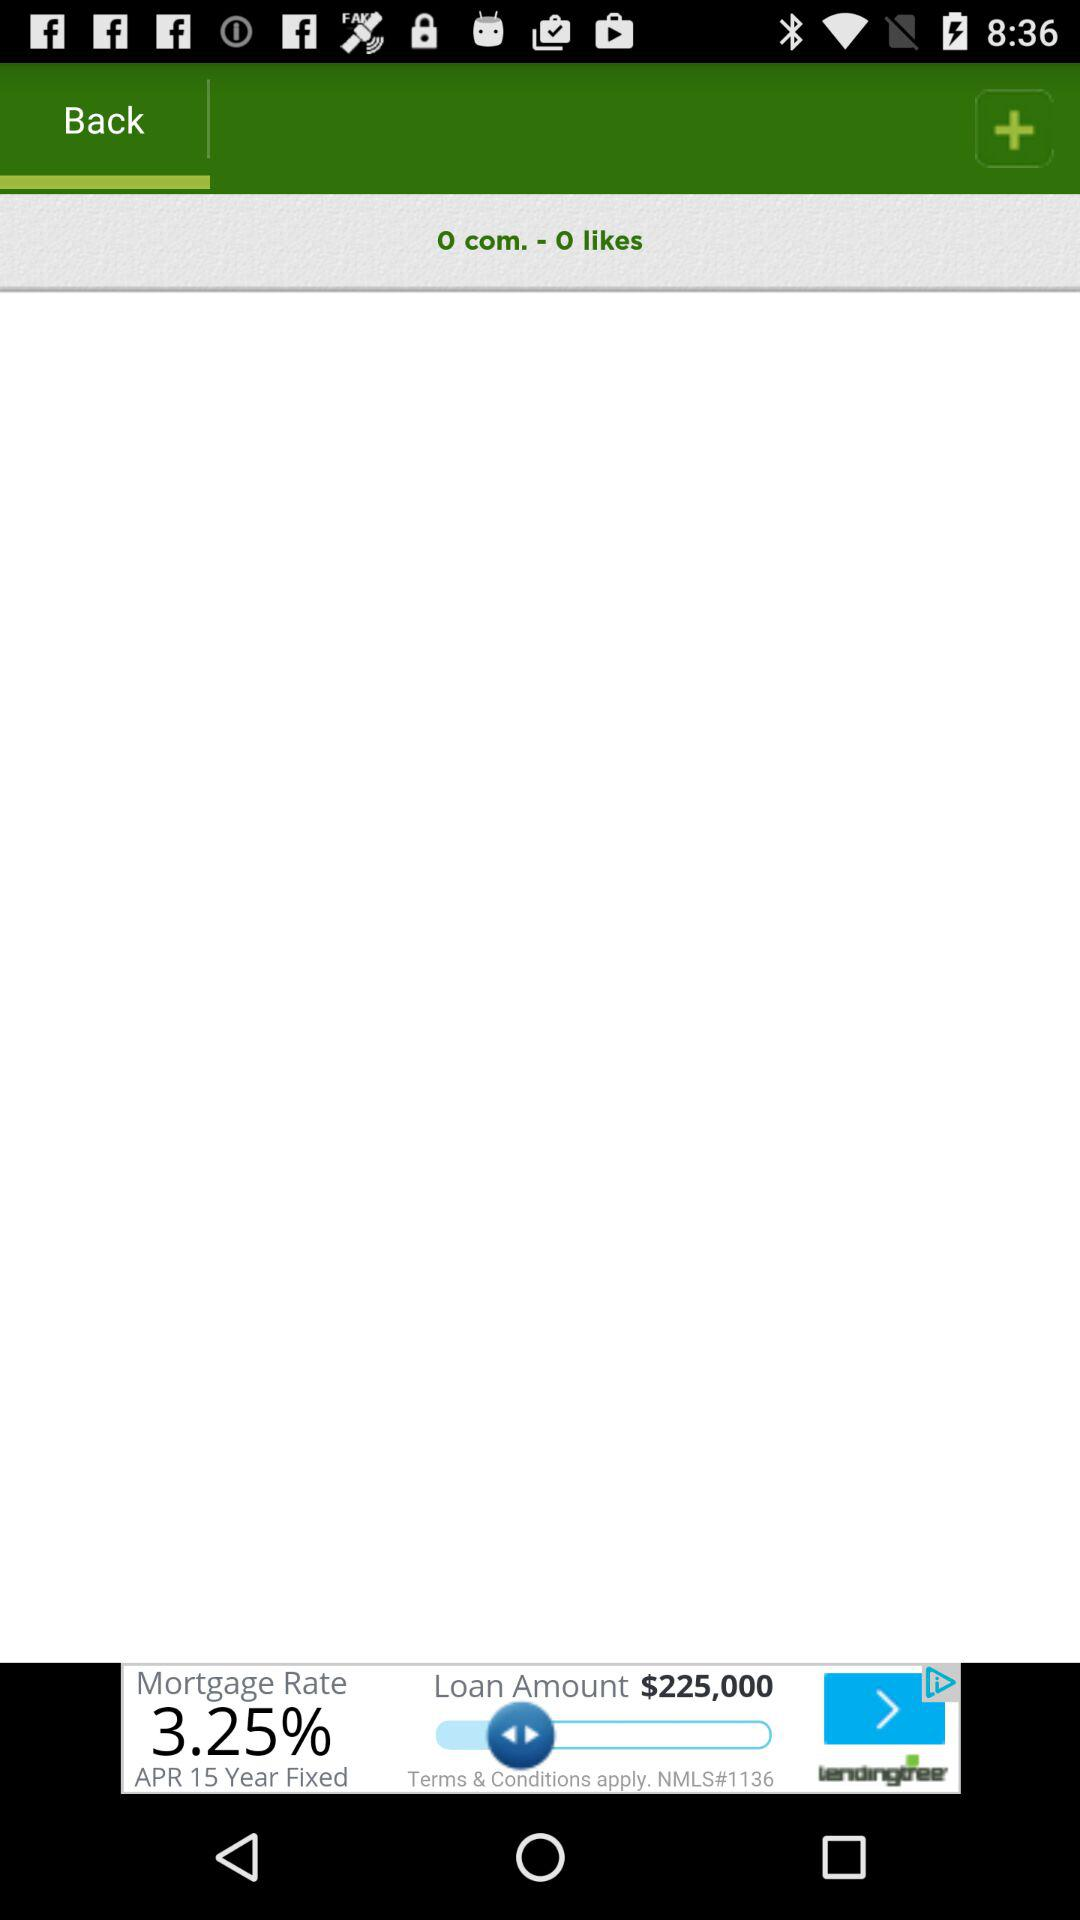How many likes are there? There are zero likes. 